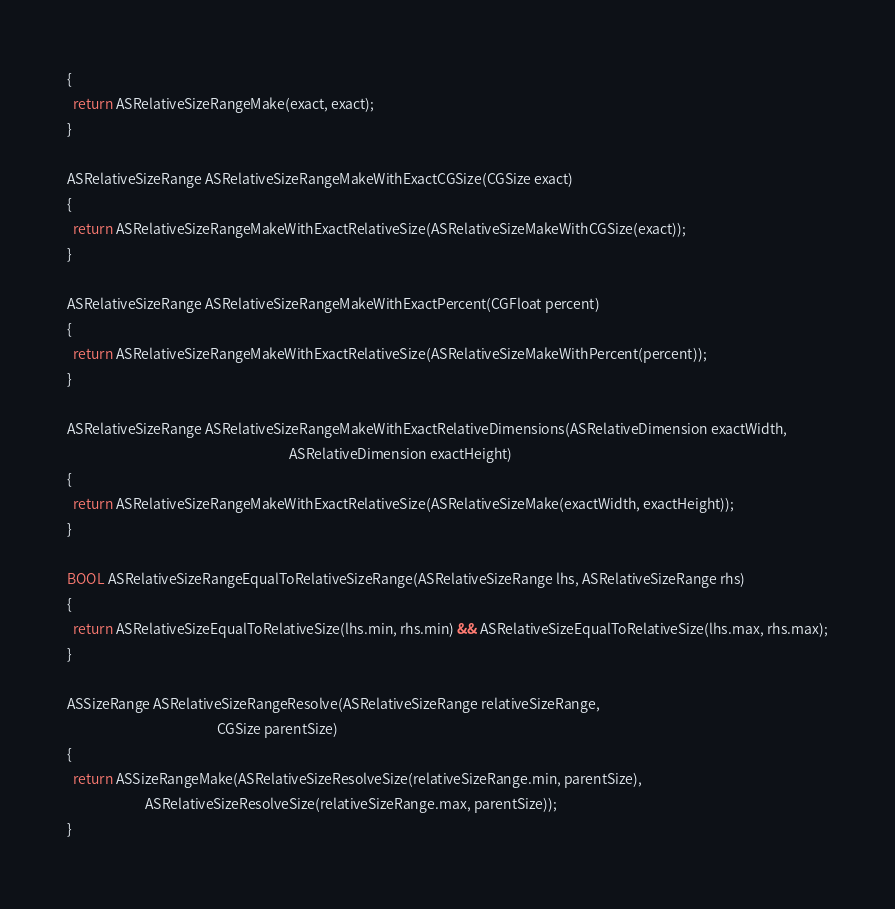<code> <loc_0><loc_0><loc_500><loc_500><_ObjectiveC_>{
  return ASRelativeSizeRangeMake(exact, exact);
}

ASRelativeSizeRange ASRelativeSizeRangeMakeWithExactCGSize(CGSize exact)
{
  return ASRelativeSizeRangeMakeWithExactRelativeSize(ASRelativeSizeMakeWithCGSize(exact));
}

ASRelativeSizeRange ASRelativeSizeRangeMakeWithExactPercent(CGFloat percent)
{
  return ASRelativeSizeRangeMakeWithExactRelativeSize(ASRelativeSizeMakeWithPercent(percent));
}

ASRelativeSizeRange ASRelativeSizeRangeMakeWithExactRelativeDimensions(ASRelativeDimension exactWidth,
                                                                       ASRelativeDimension exactHeight)
{
  return ASRelativeSizeRangeMakeWithExactRelativeSize(ASRelativeSizeMake(exactWidth, exactHeight));
}

BOOL ASRelativeSizeRangeEqualToRelativeSizeRange(ASRelativeSizeRange lhs, ASRelativeSizeRange rhs)
{
  return ASRelativeSizeEqualToRelativeSize(lhs.min, rhs.min) && ASRelativeSizeEqualToRelativeSize(lhs.max, rhs.max);
}

ASSizeRange ASRelativeSizeRangeResolve(ASRelativeSizeRange relativeSizeRange,
                                                CGSize parentSize)
{
  return ASSizeRangeMake(ASRelativeSizeResolveSize(relativeSizeRange.min, parentSize),
                         ASRelativeSizeResolveSize(relativeSizeRange.max, parentSize));
}
</code> 